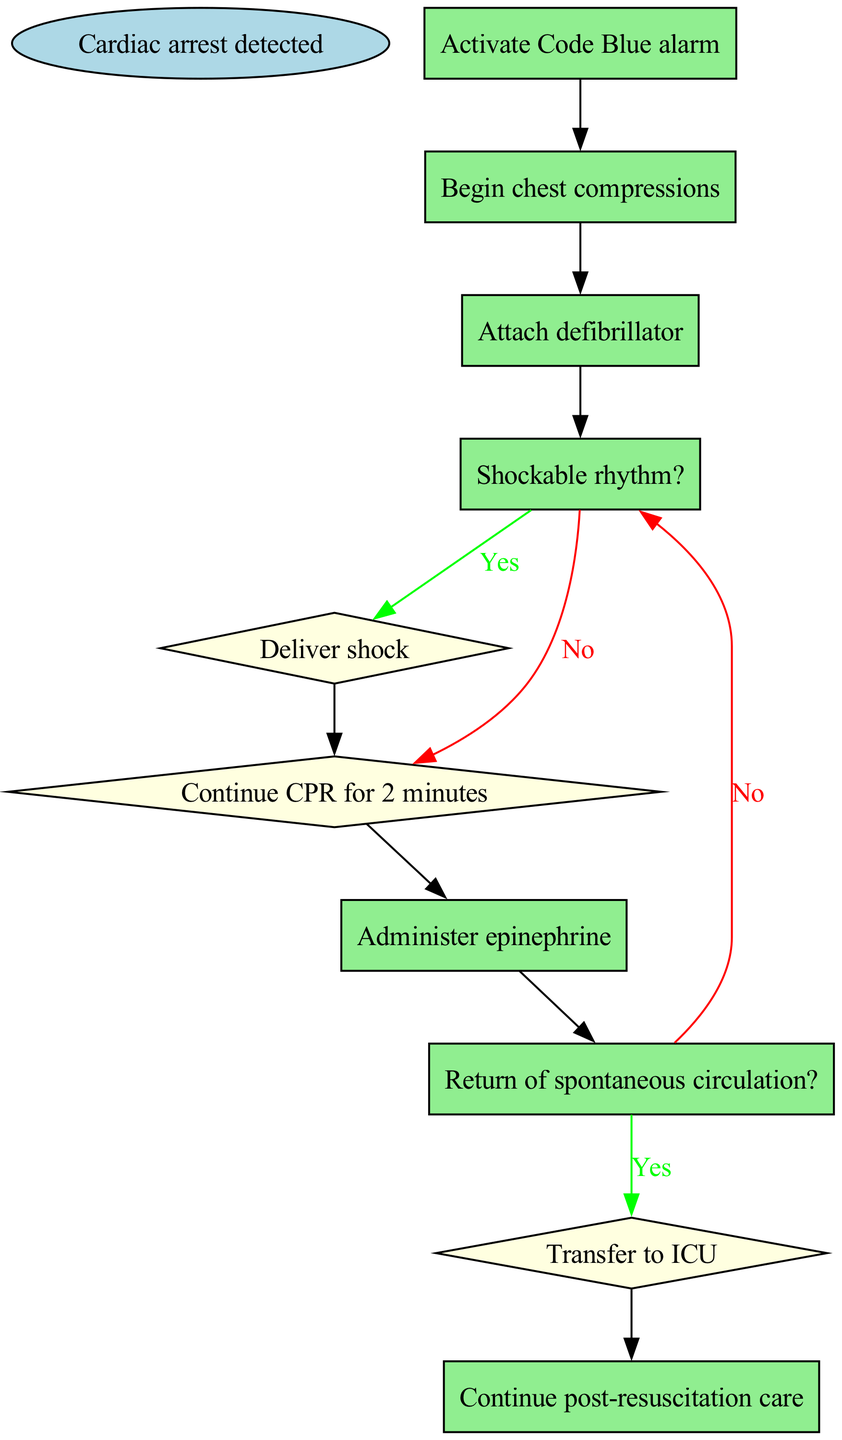What is the first action to take after cardiac arrest is detected? The diagram indicates that the first action is to "Activate Code Blue alarm", which follows the starting node labeled "Cardiac arrest detected".
Answer: Activate Code Blue alarm How many steps are in the protocol? The diagram includes a total of 8 steps (excluding the start and end nodes) detailing the actions and decisions to be made during the procedure.
Answer: 8 What happens if the rhythm is not shockable? According to the diagram, if the rhythm is not shockable, the next action is to "Continue CPR for 2 minutes", which is indicated by the node that branches from the "Shockable rhythm?" decision node.
Answer: Continue CPR for 2 minutes What is administered after continuing CPR for 2 minutes? The diagram states that after continuing CPR for 2 minutes, the next action is to "Administer epinephrine", following the flow from the previous action.
Answer: Administer epinephrine What action is taken if spontaneous circulation is not returned? The diagram indicates that if spontaneous circulation is not returned, the protocol loops back to the "Shockable rhythm?" decision point to reassess the situation before proceeding.
Answer: Shockable rhythm? What color represents the decision nodes in the diagram? The decision nodes in the diagram are represented by the color light yellow, as specified in the node styling attributes of the diagram creation process.
Answer: Light yellow Where does the flow end in this protocol? According to the diagram, the flow ends in the node labeled "Continue post-resuscitation care", which signifies the conclusion of the emergency response protocol for cardiac arrest situations.
Answer: Continue post-resuscitation care What is the action taken at step 5? The diagram specifies that at step 5, the action is to "Deliver shock", which follows from the "Shockable rhythm?" decision if the answer is yes.
Answer: Deliver shock What is the purpose of the "Attach defibrillator" step? The purpose of the "Attach defibrillator" step, indicated by step 3 in the diagram, is to prepare for further assessment of the patient’s cardiac rhythm in order to determine the appropriate response.
Answer: Prepare for assessment 